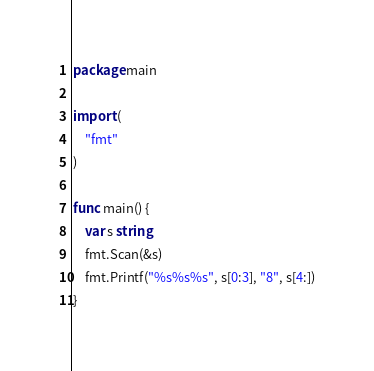Convert code to text. <code><loc_0><loc_0><loc_500><loc_500><_Go_>package main

import (
	"fmt"
)

func main() {
	var s string
	fmt.Scan(&s)
	fmt.Printf("%s%s%s", s[0:3], "8", s[4:])
}
</code> 